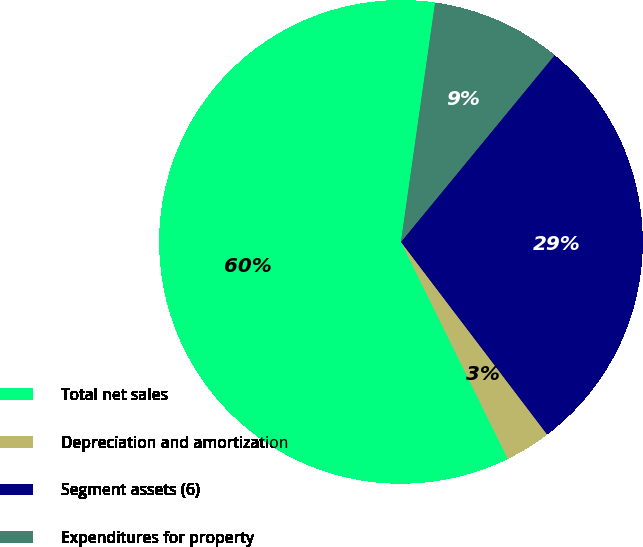<chart> <loc_0><loc_0><loc_500><loc_500><pie_chart><fcel>Total net sales<fcel>Depreciation and amortization<fcel>Segment assets (6)<fcel>Expenditures for property<nl><fcel>59.54%<fcel>3.05%<fcel>28.71%<fcel>8.7%<nl></chart> 